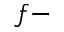<formula> <loc_0><loc_0><loc_500><loc_500>f -</formula> 